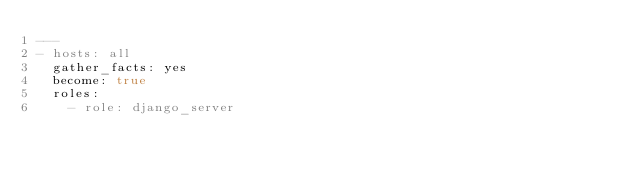<code> <loc_0><loc_0><loc_500><loc_500><_YAML_>---
- hosts: all
  gather_facts: yes
  become: true
  roles:
    - role: django_server
</code> 